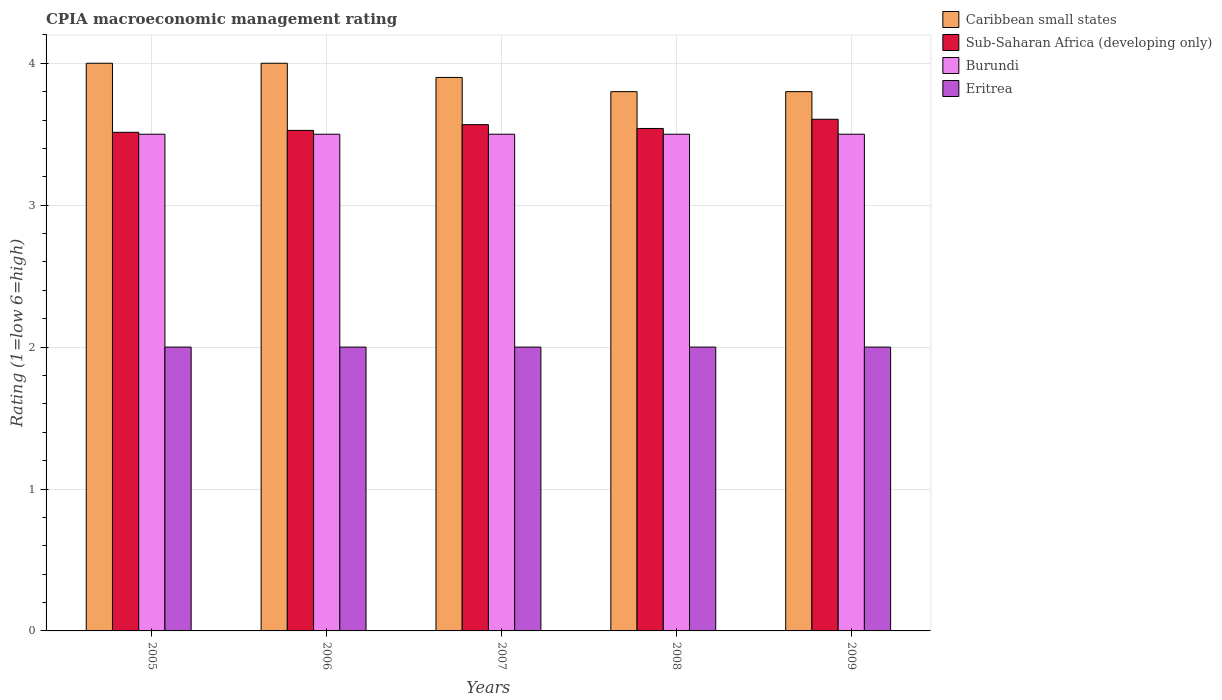How many groups of bars are there?
Keep it short and to the point. 5. Are the number of bars on each tick of the X-axis equal?
Ensure brevity in your answer.  Yes. How many bars are there on the 4th tick from the left?
Your answer should be very brief. 4. How many bars are there on the 1st tick from the right?
Your answer should be very brief. 4. What is the label of the 2nd group of bars from the left?
Provide a short and direct response. 2006. In how many cases, is the number of bars for a given year not equal to the number of legend labels?
Your response must be concise. 0. What is the CPIA rating in Eritrea in 2008?
Ensure brevity in your answer.  2. Across all years, what is the maximum CPIA rating in Caribbean small states?
Offer a terse response. 4. Across all years, what is the minimum CPIA rating in Sub-Saharan Africa (developing only)?
Offer a terse response. 3.51. In which year was the CPIA rating in Sub-Saharan Africa (developing only) maximum?
Keep it short and to the point. 2009. What is the difference between the CPIA rating in Caribbean small states in 2006 and that in 2008?
Offer a very short reply. 0.2. What is the difference between the CPIA rating in Eritrea in 2008 and the CPIA rating in Sub-Saharan Africa (developing only) in 2006?
Provide a succinct answer. -1.53. In the year 2008, what is the difference between the CPIA rating in Caribbean small states and CPIA rating in Eritrea?
Offer a terse response. 1.8. What is the ratio of the CPIA rating in Caribbean small states in 2006 to that in 2008?
Ensure brevity in your answer.  1.05. What is the difference between the highest and the lowest CPIA rating in Caribbean small states?
Keep it short and to the point. 0.2. What does the 2nd bar from the left in 2008 represents?
Keep it short and to the point. Sub-Saharan Africa (developing only). What does the 1st bar from the right in 2006 represents?
Make the answer very short. Eritrea. Are all the bars in the graph horizontal?
Your response must be concise. No. Are the values on the major ticks of Y-axis written in scientific E-notation?
Offer a very short reply. No. Does the graph contain any zero values?
Ensure brevity in your answer.  No. Does the graph contain grids?
Your answer should be compact. Yes. How many legend labels are there?
Make the answer very short. 4. How are the legend labels stacked?
Make the answer very short. Vertical. What is the title of the graph?
Provide a short and direct response. CPIA macroeconomic management rating. What is the label or title of the X-axis?
Ensure brevity in your answer.  Years. What is the Rating (1=low 6=high) of Caribbean small states in 2005?
Make the answer very short. 4. What is the Rating (1=low 6=high) in Sub-Saharan Africa (developing only) in 2005?
Provide a short and direct response. 3.51. What is the Rating (1=low 6=high) of Burundi in 2005?
Keep it short and to the point. 3.5. What is the Rating (1=low 6=high) of Sub-Saharan Africa (developing only) in 2006?
Your response must be concise. 3.53. What is the Rating (1=low 6=high) of Burundi in 2006?
Keep it short and to the point. 3.5. What is the Rating (1=low 6=high) of Eritrea in 2006?
Make the answer very short. 2. What is the Rating (1=low 6=high) of Caribbean small states in 2007?
Give a very brief answer. 3.9. What is the Rating (1=low 6=high) in Sub-Saharan Africa (developing only) in 2007?
Your answer should be very brief. 3.57. What is the Rating (1=low 6=high) in Burundi in 2007?
Offer a terse response. 3.5. What is the Rating (1=low 6=high) of Eritrea in 2007?
Give a very brief answer. 2. What is the Rating (1=low 6=high) of Sub-Saharan Africa (developing only) in 2008?
Give a very brief answer. 3.54. What is the Rating (1=low 6=high) of Caribbean small states in 2009?
Your answer should be compact. 3.8. What is the Rating (1=low 6=high) in Sub-Saharan Africa (developing only) in 2009?
Provide a succinct answer. 3.61. What is the Rating (1=low 6=high) in Burundi in 2009?
Keep it short and to the point. 3.5. Across all years, what is the maximum Rating (1=low 6=high) in Sub-Saharan Africa (developing only)?
Keep it short and to the point. 3.61. Across all years, what is the maximum Rating (1=low 6=high) in Eritrea?
Offer a very short reply. 2. Across all years, what is the minimum Rating (1=low 6=high) in Caribbean small states?
Give a very brief answer. 3.8. Across all years, what is the minimum Rating (1=low 6=high) of Sub-Saharan Africa (developing only)?
Provide a short and direct response. 3.51. What is the total Rating (1=low 6=high) in Caribbean small states in the graph?
Your answer should be very brief. 19.5. What is the total Rating (1=low 6=high) of Sub-Saharan Africa (developing only) in the graph?
Ensure brevity in your answer.  17.75. What is the difference between the Rating (1=low 6=high) in Sub-Saharan Africa (developing only) in 2005 and that in 2006?
Offer a very short reply. -0.01. What is the difference between the Rating (1=low 6=high) in Sub-Saharan Africa (developing only) in 2005 and that in 2007?
Offer a very short reply. -0.05. What is the difference between the Rating (1=low 6=high) of Burundi in 2005 and that in 2007?
Make the answer very short. 0. What is the difference between the Rating (1=low 6=high) of Sub-Saharan Africa (developing only) in 2005 and that in 2008?
Your response must be concise. -0.03. What is the difference between the Rating (1=low 6=high) of Caribbean small states in 2005 and that in 2009?
Give a very brief answer. 0.2. What is the difference between the Rating (1=low 6=high) in Sub-Saharan Africa (developing only) in 2005 and that in 2009?
Your response must be concise. -0.09. What is the difference between the Rating (1=low 6=high) of Eritrea in 2005 and that in 2009?
Your answer should be compact. 0. What is the difference between the Rating (1=low 6=high) of Caribbean small states in 2006 and that in 2007?
Your answer should be compact. 0.1. What is the difference between the Rating (1=low 6=high) of Sub-Saharan Africa (developing only) in 2006 and that in 2007?
Your answer should be very brief. -0.04. What is the difference between the Rating (1=low 6=high) of Eritrea in 2006 and that in 2007?
Your response must be concise. 0. What is the difference between the Rating (1=low 6=high) of Sub-Saharan Africa (developing only) in 2006 and that in 2008?
Make the answer very short. -0.01. What is the difference between the Rating (1=low 6=high) in Sub-Saharan Africa (developing only) in 2006 and that in 2009?
Your answer should be very brief. -0.08. What is the difference between the Rating (1=low 6=high) of Eritrea in 2006 and that in 2009?
Offer a terse response. 0. What is the difference between the Rating (1=low 6=high) in Caribbean small states in 2007 and that in 2008?
Offer a terse response. 0.1. What is the difference between the Rating (1=low 6=high) in Sub-Saharan Africa (developing only) in 2007 and that in 2008?
Ensure brevity in your answer.  0.03. What is the difference between the Rating (1=low 6=high) in Caribbean small states in 2007 and that in 2009?
Provide a succinct answer. 0.1. What is the difference between the Rating (1=low 6=high) in Sub-Saharan Africa (developing only) in 2007 and that in 2009?
Keep it short and to the point. -0.04. What is the difference between the Rating (1=low 6=high) of Sub-Saharan Africa (developing only) in 2008 and that in 2009?
Make the answer very short. -0.06. What is the difference between the Rating (1=low 6=high) of Burundi in 2008 and that in 2009?
Offer a terse response. 0. What is the difference between the Rating (1=low 6=high) in Caribbean small states in 2005 and the Rating (1=low 6=high) in Sub-Saharan Africa (developing only) in 2006?
Give a very brief answer. 0.47. What is the difference between the Rating (1=low 6=high) in Caribbean small states in 2005 and the Rating (1=low 6=high) in Burundi in 2006?
Your response must be concise. 0.5. What is the difference between the Rating (1=low 6=high) in Sub-Saharan Africa (developing only) in 2005 and the Rating (1=low 6=high) in Burundi in 2006?
Make the answer very short. 0.01. What is the difference between the Rating (1=low 6=high) of Sub-Saharan Africa (developing only) in 2005 and the Rating (1=low 6=high) of Eritrea in 2006?
Offer a very short reply. 1.51. What is the difference between the Rating (1=low 6=high) in Caribbean small states in 2005 and the Rating (1=low 6=high) in Sub-Saharan Africa (developing only) in 2007?
Offer a terse response. 0.43. What is the difference between the Rating (1=low 6=high) of Sub-Saharan Africa (developing only) in 2005 and the Rating (1=low 6=high) of Burundi in 2007?
Provide a succinct answer. 0.01. What is the difference between the Rating (1=low 6=high) of Sub-Saharan Africa (developing only) in 2005 and the Rating (1=low 6=high) of Eritrea in 2007?
Provide a succinct answer. 1.51. What is the difference between the Rating (1=low 6=high) in Burundi in 2005 and the Rating (1=low 6=high) in Eritrea in 2007?
Your answer should be compact. 1.5. What is the difference between the Rating (1=low 6=high) of Caribbean small states in 2005 and the Rating (1=low 6=high) of Sub-Saharan Africa (developing only) in 2008?
Keep it short and to the point. 0.46. What is the difference between the Rating (1=low 6=high) in Caribbean small states in 2005 and the Rating (1=low 6=high) in Burundi in 2008?
Your response must be concise. 0.5. What is the difference between the Rating (1=low 6=high) in Sub-Saharan Africa (developing only) in 2005 and the Rating (1=low 6=high) in Burundi in 2008?
Provide a short and direct response. 0.01. What is the difference between the Rating (1=low 6=high) of Sub-Saharan Africa (developing only) in 2005 and the Rating (1=low 6=high) of Eritrea in 2008?
Keep it short and to the point. 1.51. What is the difference between the Rating (1=low 6=high) in Caribbean small states in 2005 and the Rating (1=low 6=high) in Sub-Saharan Africa (developing only) in 2009?
Ensure brevity in your answer.  0.39. What is the difference between the Rating (1=low 6=high) in Caribbean small states in 2005 and the Rating (1=low 6=high) in Eritrea in 2009?
Make the answer very short. 2. What is the difference between the Rating (1=low 6=high) in Sub-Saharan Africa (developing only) in 2005 and the Rating (1=low 6=high) in Burundi in 2009?
Your response must be concise. 0.01. What is the difference between the Rating (1=low 6=high) in Sub-Saharan Africa (developing only) in 2005 and the Rating (1=low 6=high) in Eritrea in 2009?
Ensure brevity in your answer.  1.51. What is the difference between the Rating (1=low 6=high) in Caribbean small states in 2006 and the Rating (1=low 6=high) in Sub-Saharan Africa (developing only) in 2007?
Provide a succinct answer. 0.43. What is the difference between the Rating (1=low 6=high) in Caribbean small states in 2006 and the Rating (1=low 6=high) in Burundi in 2007?
Give a very brief answer. 0.5. What is the difference between the Rating (1=low 6=high) of Sub-Saharan Africa (developing only) in 2006 and the Rating (1=low 6=high) of Burundi in 2007?
Your answer should be compact. 0.03. What is the difference between the Rating (1=low 6=high) of Sub-Saharan Africa (developing only) in 2006 and the Rating (1=low 6=high) of Eritrea in 2007?
Offer a terse response. 1.53. What is the difference between the Rating (1=low 6=high) of Burundi in 2006 and the Rating (1=low 6=high) of Eritrea in 2007?
Your answer should be very brief. 1.5. What is the difference between the Rating (1=low 6=high) in Caribbean small states in 2006 and the Rating (1=low 6=high) in Sub-Saharan Africa (developing only) in 2008?
Keep it short and to the point. 0.46. What is the difference between the Rating (1=low 6=high) of Caribbean small states in 2006 and the Rating (1=low 6=high) of Burundi in 2008?
Keep it short and to the point. 0.5. What is the difference between the Rating (1=low 6=high) of Sub-Saharan Africa (developing only) in 2006 and the Rating (1=low 6=high) of Burundi in 2008?
Your answer should be very brief. 0.03. What is the difference between the Rating (1=low 6=high) of Sub-Saharan Africa (developing only) in 2006 and the Rating (1=low 6=high) of Eritrea in 2008?
Your response must be concise. 1.53. What is the difference between the Rating (1=low 6=high) in Burundi in 2006 and the Rating (1=low 6=high) in Eritrea in 2008?
Make the answer very short. 1.5. What is the difference between the Rating (1=low 6=high) in Caribbean small states in 2006 and the Rating (1=low 6=high) in Sub-Saharan Africa (developing only) in 2009?
Give a very brief answer. 0.39. What is the difference between the Rating (1=low 6=high) in Caribbean small states in 2006 and the Rating (1=low 6=high) in Eritrea in 2009?
Give a very brief answer. 2. What is the difference between the Rating (1=low 6=high) of Sub-Saharan Africa (developing only) in 2006 and the Rating (1=low 6=high) of Burundi in 2009?
Your answer should be compact. 0.03. What is the difference between the Rating (1=low 6=high) in Sub-Saharan Africa (developing only) in 2006 and the Rating (1=low 6=high) in Eritrea in 2009?
Give a very brief answer. 1.53. What is the difference between the Rating (1=low 6=high) of Burundi in 2006 and the Rating (1=low 6=high) of Eritrea in 2009?
Provide a short and direct response. 1.5. What is the difference between the Rating (1=low 6=high) in Caribbean small states in 2007 and the Rating (1=low 6=high) in Sub-Saharan Africa (developing only) in 2008?
Give a very brief answer. 0.36. What is the difference between the Rating (1=low 6=high) in Sub-Saharan Africa (developing only) in 2007 and the Rating (1=low 6=high) in Burundi in 2008?
Provide a succinct answer. 0.07. What is the difference between the Rating (1=low 6=high) of Sub-Saharan Africa (developing only) in 2007 and the Rating (1=low 6=high) of Eritrea in 2008?
Make the answer very short. 1.57. What is the difference between the Rating (1=low 6=high) in Burundi in 2007 and the Rating (1=low 6=high) in Eritrea in 2008?
Your response must be concise. 1.5. What is the difference between the Rating (1=low 6=high) of Caribbean small states in 2007 and the Rating (1=low 6=high) of Sub-Saharan Africa (developing only) in 2009?
Provide a succinct answer. 0.29. What is the difference between the Rating (1=low 6=high) of Caribbean small states in 2007 and the Rating (1=low 6=high) of Burundi in 2009?
Keep it short and to the point. 0.4. What is the difference between the Rating (1=low 6=high) of Sub-Saharan Africa (developing only) in 2007 and the Rating (1=low 6=high) of Burundi in 2009?
Provide a succinct answer. 0.07. What is the difference between the Rating (1=low 6=high) of Sub-Saharan Africa (developing only) in 2007 and the Rating (1=low 6=high) of Eritrea in 2009?
Offer a terse response. 1.57. What is the difference between the Rating (1=low 6=high) of Burundi in 2007 and the Rating (1=low 6=high) of Eritrea in 2009?
Offer a very short reply. 1.5. What is the difference between the Rating (1=low 6=high) in Caribbean small states in 2008 and the Rating (1=low 6=high) in Sub-Saharan Africa (developing only) in 2009?
Keep it short and to the point. 0.19. What is the difference between the Rating (1=low 6=high) of Caribbean small states in 2008 and the Rating (1=low 6=high) of Burundi in 2009?
Offer a terse response. 0.3. What is the difference between the Rating (1=low 6=high) of Sub-Saharan Africa (developing only) in 2008 and the Rating (1=low 6=high) of Burundi in 2009?
Offer a very short reply. 0.04. What is the difference between the Rating (1=low 6=high) in Sub-Saharan Africa (developing only) in 2008 and the Rating (1=low 6=high) in Eritrea in 2009?
Provide a succinct answer. 1.54. What is the average Rating (1=low 6=high) of Sub-Saharan Africa (developing only) per year?
Your response must be concise. 3.55. In the year 2005, what is the difference between the Rating (1=low 6=high) of Caribbean small states and Rating (1=low 6=high) of Sub-Saharan Africa (developing only)?
Your response must be concise. 0.49. In the year 2005, what is the difference between the Rating (1=low 6=high) of Sub-Saharan Africa (developing only) and Rating (1=low 6=high) of Burundi?
Provide a succinct answer. 0.01. In the year 2005, what is the difference between the Rating (1=low 6=high) of Sub-Saharan Africa (developing only) and Rating (1=low 6=high) of Eritrea?
Your answer should be very brief. 1.51. In the year 2005, what is the difference between the Rating (1=low 6=high) of Burundi and Rating (1=low 6=high) of Eritrea?
Make the answer very short. 1.5. In the year 2006, what is the difference between the Rating (1=low 6=high) in Caribbean small states and Rating (1=low 6=high) in Sub-Saharan Africa (developing only)?
Ensure brevity in your answer.  0.47. In the year 2006, what is the difference between the Rating (1=low 6=high) in Caribbean small states and Rating (1=low 6=high) in Burundi?
Keep it short and to the point. 0.5. In the year 2006, what is the difference between the Rating (1=low 6=high) in Sub-Saharan Africa (developing only) and Rating (1=low 6=high) in Burundi?
Provide a succinct answer. 0.03. In the year 2006, what is the difference between the Rating (1=low 6=high) of Sub-Saharan Africa (developing only) and Rating (1=low 6=high) of Eritrea?
Your answer should be compact. 1.53. In the year 2007, what is the difference between the Rating (1=low 6=high) in Caribbean small states and Rating (1=low 6=high) in Sub-Saharan Africa (developing only)?
Ensure brevity in your answer.  0.33. In the year 2007, what is the difference between the Rating (1=low 6=high) in Caribbean small states and Rating (1=low 6=high) in Burundi?
Provide a short and direct response. 0.4. In the year 2007, what is the difference between the Rating (1=low 6=high) in Sub-Saharan Africa (developing only) and Rating (1=low 6=high) in Burundi?
Your answer should be very brief. 0.07. In the year 2007, what is the difference between the Rating (1=low 6=high) in Sub-Saharan Africa (developing only) and Rating (1=low 6=high) in Eritrea?
Ensure brevity in your answer.  1.57. In the year 2007, what is the difference between the Rating (1=low 6=high) of Burundi and Rating (1=low 6=high) of Eritrea?
Ensure brevity in your answer.  1.5. In the year 2008, what is the difference between the Rating (1=low 6=high) in Caribbean small states and Rating (1=low 6=high) in Sub-Saharan Africa (developing only)?
Provide a short and direct response. 0.26. In the year 2008, what is the difference between the Rating (1=low 6=high) of Caribbean small states and Rating (1=low 6=high) of Burundi?
Keep it short and to the point. 0.3. In the year 2008, what is the difference between the Rating (1=low 6=high) in Sub-Saharan Africa (developing only) and Rating (1=low 6=high) in Burundi?
Offer a terse response. 0.04. In the year 2008, what is the difference between the Rating (1=low 6=high) of Sub-Saharan Africa (developing only) and Rating (1=low 6=high) of Eritrea?
Give a very brief answer. 1.54. In the year 2008, what is the difference between the Rating (1=low 6=high) in Burundi and Rating (1=low 6=high) in Eritrea?
Offer a terse response. 1.5. In the year 2009, what is the difference between the Rating (1=low 6=high) of Caribbean small states and Rating (1=low 6=high) of Sub-Saharan Africa (developing only)?
Give a very brief answer. 0.19. In the year 2009, what is the difference between the Rating (1=low 6=high) in Sub-Saharan Africa (developing only) and Rating (1=low 6=high) in Burundi?
Provide a succinct answer. 0.11. In the year 2009, what is the difference between the Rating (1=low 6=high) of Sub-Saharan Africa (developing only) and Rating (1=low 6=high) of Eritrea?
Offer a terse response. 1.61. In the year 2009, what is the difference between the Rating (1=low 6=high) in Burundi and Rating (1=low 6=high) in Eritrea?
Ensure brevity in your answer.  1.5. What is the ratio of the Rating (1=low 6=high) of Caribbean small states in 2005 to that in 2006?
Provide a succinct answer. 1. What is the ratio of the Rating (1=low 6=high) in Burundi in 2005 to that in 2006?
Your response must be concise. 1. What is the ratio of the Rating (1=low 6=high) in Caribbean small states in 2005 to that in 2007?
Offer a terse response. 1.03. What is the ratio of the Rating (1=low 6=high) in Sub-Saharan Africa (developing only) in 2005 to that in 2007?
Offer a very short reply. 0.98. What is the ratio of the Rating (1=low 6=high) of Eritrea in 2005 to that in 2007?
Make the answer very short. 1. What is the ratio of the Rating (1=low 6=high) of Caribbean small states in 2005 to that in 2008?
Offer a terse response. 1.05. What is the ratio of the Rating (1=low 6=high) in Caribbean small states in 2005 to that in 2009?
Provide a succinct answer. 1.05. What is the ratio of the Rating (1=low 6=high) in Sub-Saharan Africa (developing only) in 2005 to that in 2009?
Offer a very short reply. 0.97. What is the ratio of the Rating (1=low 6=high) of Burundi in 2005 to that in 2009?
Your response must be concise. 1. What is the ratio of the Rating (1=low 6=high) of Caribbean small states in 2006 to that in 2007?
Provide a succinct answer. 1.03. What is the ratio of the Rating (1=low 6=high) of Sub-Saharan Africa (developing only) in 2006 to that in 2007?
Offer a terse response. 0.99. What is the ratio of the Rating (1=low 6=high) of Eritrea in 2006 to that in 2007?
Keep it short and to the point. 1. What is the ratio of the Rating (1=low 6=high) in Caribbean small states in 2006 to that in 2008?
Your response must be concise. 1.05. What is the ratio of the Rating (1=low 6=high) of Burundi in 2006 to that in 2008?
Your answer should be very brief. 1. What is the ratio of the Rating (1=low 6=high) of Eritrea in 2006 to that in 2008?
Provide a short and direct response. 1. What is the ratio of the Rating (1=low 6=high) of Caribbean small states in 2006 to that in 2009?
Ensure brevity in your answer.  1.05. What is the ratio of the Rating (1=low 6=high) in Sub-Saharan Africa (developing only) in 2006 to that in 2009?
Offer a very short reply. 0.98. What is the ratio of the Rating (1=low 6=high) in Caribbean small states in 2007 to that in 2008?
Provide a short and direct response. 1.03. What is the ratio of the Rating (1=low 6=high) of Sub-Saharan Africa (developing only) in 2007 to that in 2008?
Give a very brief answer. 1.01. What is the ratio of the Rating (1=low 6=high) in Burundi in 2007 to that in 2008?
Make the answer very short. 1. What is the ratio of the Rating (1=low 6=high) in Eritrea in 2007 to that in 2008?
Ensure brevity in your answer.  1. What is the ratio of the Rating (1=low 6=high) of Caribbean small states in 2007 to that in 2009?
Provide a short and direct response. 1.03. What is the ratio of the Rating (1=low 6=high) of Eritrea in 2007 to that in 2009?
Give a very brief answer. 1. What is the ratio of the Rating (1=low 6=high) in Eritrea in 2008 to that in 2009?
Your answer should be compact. 1. What is the difference between the highest and the second highest Rating (1=low 6=high) in Sub-Saharan Africa (developing only)?
Your response must be concise. 0.04. What is the difference between the highest and the second highest Rating (1=low 6=high) of Eritrea?
Make the answer very short. 0. What is the difference between the highest and the lowest Rating (1=low 6=high) of Sub-Saharan Africa (developing only)?
Your answer should be compact. 0.09. What is the difference between the highest and the lowest Rating (1=low 6=high) of Eritrea?
Keep it short and to the point. 0. 